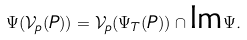<formula> <loc_0><loc_0><loc_500><loc_500>\Psi ( \mathcal { V } _ { p } ( P ) ) = \mathcal { V } _ { p } ( \Psi _ { T } ( P ) ) \cap \text {Im} \Psi .</formula> 